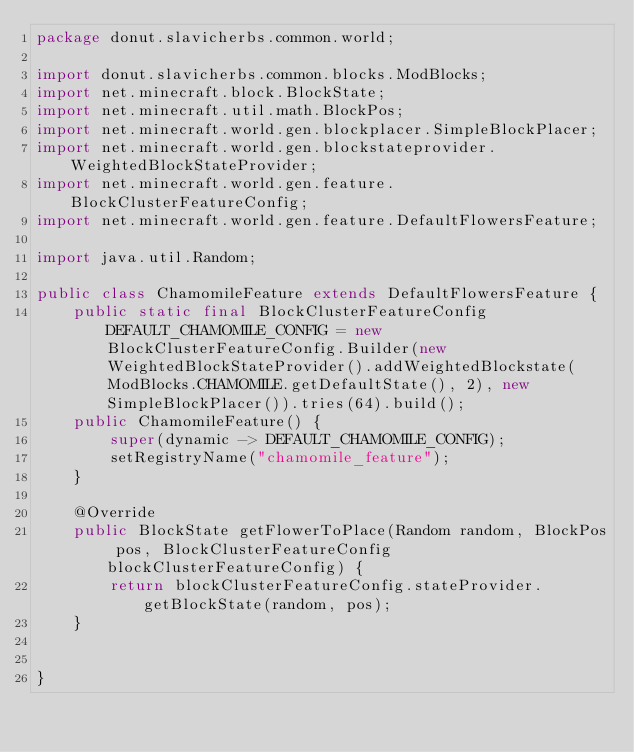Convert code to text. <code><loc_0><loc_0><loc_500><loc_500><_Java_>package donut.slavicherbs.common.world;

import donut.slavicherbs.common.blocks.ModBlocks;
import net.minecraft.block.BlockState;
import net.minecraft.util.math.BlockPos;
import net.minecraft.world.gen.blockplacer.SimpleBlockPlacer;
import net.minecraft.world.gen.blockstateprovider.WeightedBlockStateProvider;
import net.minecraft.world.gen.feature.BlockClusterFeatureConfig;
import net.minecraft.world.gen.feature.DefaultFlowersFeature;

import java.util.Random;

public class ChamomileFeature extends DefaultFlowersFeature {
    public static final BlockClusterFeatureConfig DEFAULT_CHAMOMILE_CONFIG = new BlockClusterFeatureConfig.Builder(new WeightedBlockStateProvider().addWeightedBlockstate(ModBlocks.CHAMOMILE.getDefaultState(), 2), new SimpleBlockPlacer()).tries(64).build();
    public ChamomileFeature() {
        super(dynamic -> DEFAULT_CHAMOMILE_CONFIG);
        setRegistryName("chamomile_feature");
    }

    @Override
    public BlockState getFlowerToPlace(Random random, BlockPos pos, BlockClusterFeatureConfig blockClusterFeatureConfig) {
        return blockClusterFeatureConfig.stateProvider.getBlockState(random, pos);
    }


}
</code> 